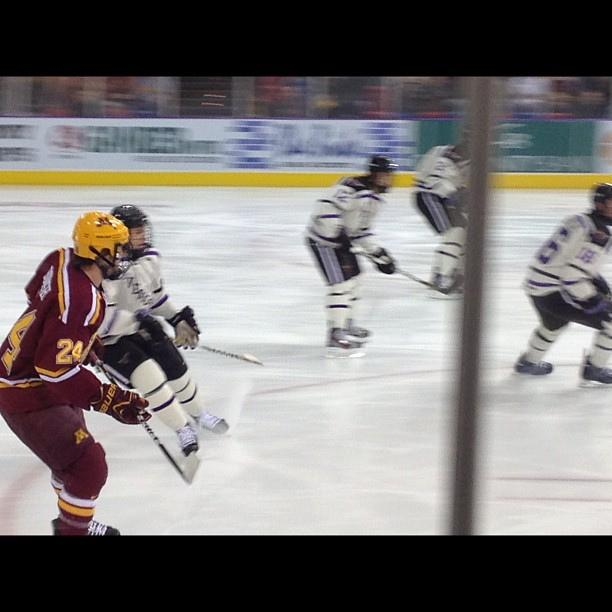What foot appeared are the hockey players wearing to play on the ice? Please explain your reasoning. skates. Hockey players play on ice and wear skates in order to do that. 